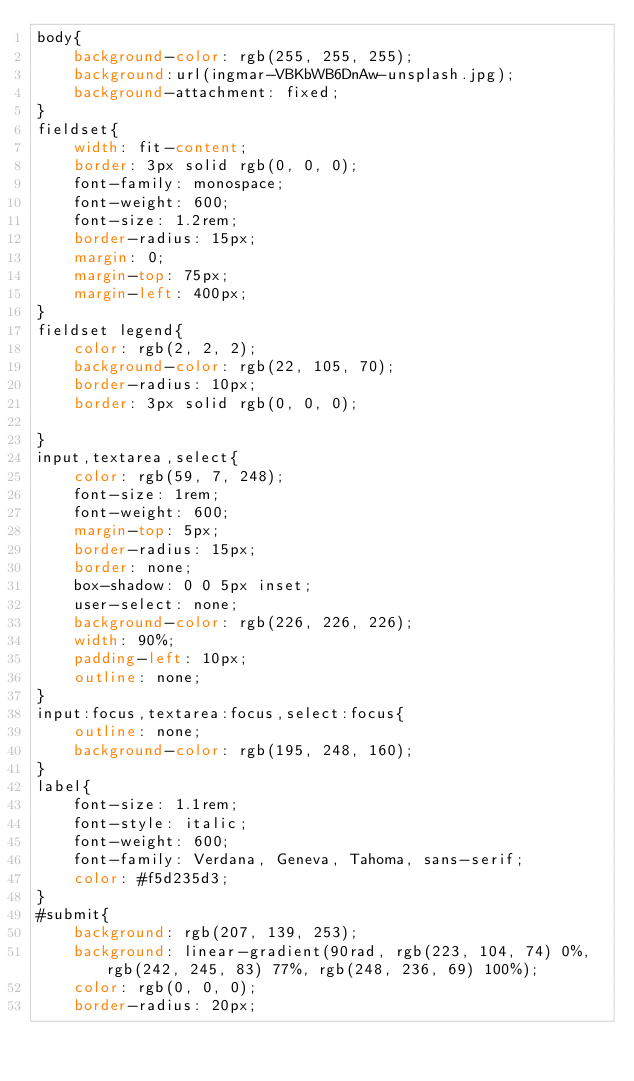Convert code to text. <code><loc_0><loc_0><loc_500><loc_500><_CSS_>body{
    background-color: rgb(255, 255, 255);
    background:url(ingmar-VBKbWB6DnAw-unsplash.jpg);
    background-attachment: fixed;
}
fieldset{
    width: fit-content;
    border: 3px solid rgb(0, 0, 0);
    font-family: monospace;
    font-weight: 600;
    font-size: 1.2rem;
    border-radius: 15px;
    margin: 0;
    margin-top: 75px;
    margin-left: 400px;
}
fieldset legend{
    color: rgb(2, 2, 2);
    background-color: rgb(22, 105, 70);
    border-radius: 10px;
    border: 3px solid rgb(0, 0, 0);

}
input,textarea,select{
    color: rgb(59, 7, 248);
    font-size: 1rem;
    font-weight: 600;
    margin-top: 5px;
    border-radius: 15px;
    border: none;
    box-shadow: 0 0 5px inset;
    user-select: none;
    background-color: rgb(226, 226, 226);
    width: 90%;
    padding-left: 10px;
    outline: none;
}
input:focus,textarea:focus,select:focus{
    outline: none;
    background-color: rgb(195, 248, 160);
}
label{
    font-size: 1.1rem;
    font-style: italic;
    font-weight: 600;
    font-family: Verdana, Geneva, Tahoma, sans-serif;
    color: #f5d235d3;
}
#submit{
    background: rgb(207, 139, 253);
    background: linear-gradient(90rad, rgb(223, 104, 74) 0%, rgb(242, 245, 83) 77%, rgb(248, 236, 69) 100%);
    color: rgb(0, 0, 0);
    border-radius: 20px;</code> 